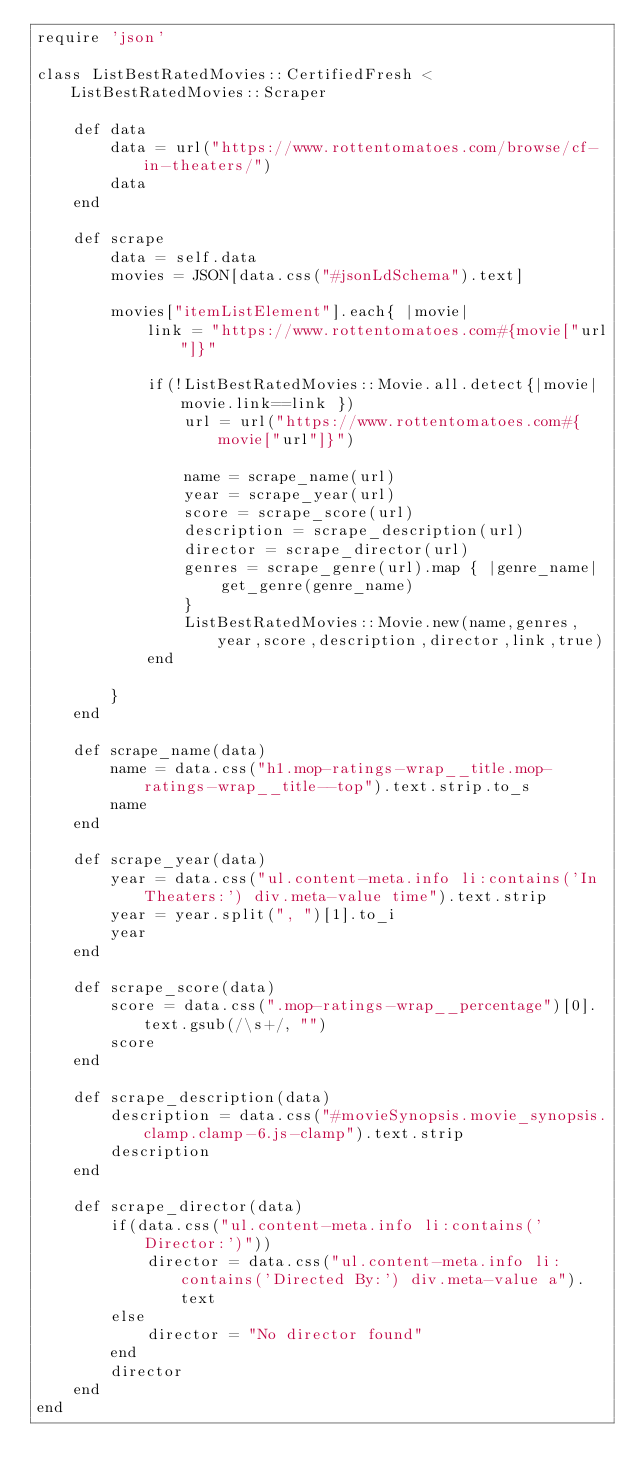<code> <loc_0><loc_0><loc_500><loc_500><_Ruby_>require 'json'

class ListBestRatedMovies::CertifiedFresh < ListBestRatedMovies::Scraper

    def data
        data = url("https://www.rottentomatoes.com/browse/cf-in-theaters/")
        data
    end

    def scrape
        data = self.data
        movies = JSON[data.css("#jsonLdSchema").text]

        movies["itemListElement"].each{ |movie|
            link = "https://www.rottentomatoes.com#{movie["url"]}"

            if(!ListBestRatedMovies::Movie.all.detect{|movie| movie.link==link }) 
                url = url("https://www.rottentomatoes.com#{movie["url"]}")
                
                name = scrape_name(url)
                year = scrape_year(url)
                score = scrape_score(url)
                description = scrape_description(url)
                director = scrape_director(url)
                genres = scrape_genre(url).map { |genre_name|
                    get_genre(genre_name)  
                }
                ListBestRatedMovies::Movie.new(name,genres,year,score,description,director,link,true)
            end
            
        }
    end

    def scrape_name(data)
        name = data.css("h1.mop-ratings-wrap__title.mop-ratings-wrap__title--top").text.strip.to_s
        name
    end

    def scrape_year(data)
        year = data.css("ul.content-meta.info li:contains('In Theaters:') div.meta-value time").text.strip
        year = year.split(", ")[1].to_i
        year
    end

    def scrape_score(data)
        score = data.css(".mop-ratings-wrap__percentage")[0].text.gsub(/\s+/, "")
        score
    end

    def scrape_description(data)
        description = data.css("#movieSynopsis.movie_synopsis.clamp.clamp-6.js-clamp").text.strip
        description
    end

    def scrape_director(data)
        if(data.css("ul.content-meta.info li:contains('Director:')"))
            director = data.css("ul.content-meta.info li:contains('Directed By:') div.meta-value a").text
        else
            director = "No director found"
        end
        director
    end
end

</code> 